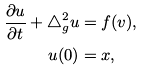Convert formula to latex. <formula><loc_0><loc_0><loc_500><loc_500>\frac { \partial u } { \partial t } + \triangle ^ { 2 } _ { g } u & = f ( v ) , \\ u ( 0 ) & = x ,</formula> 